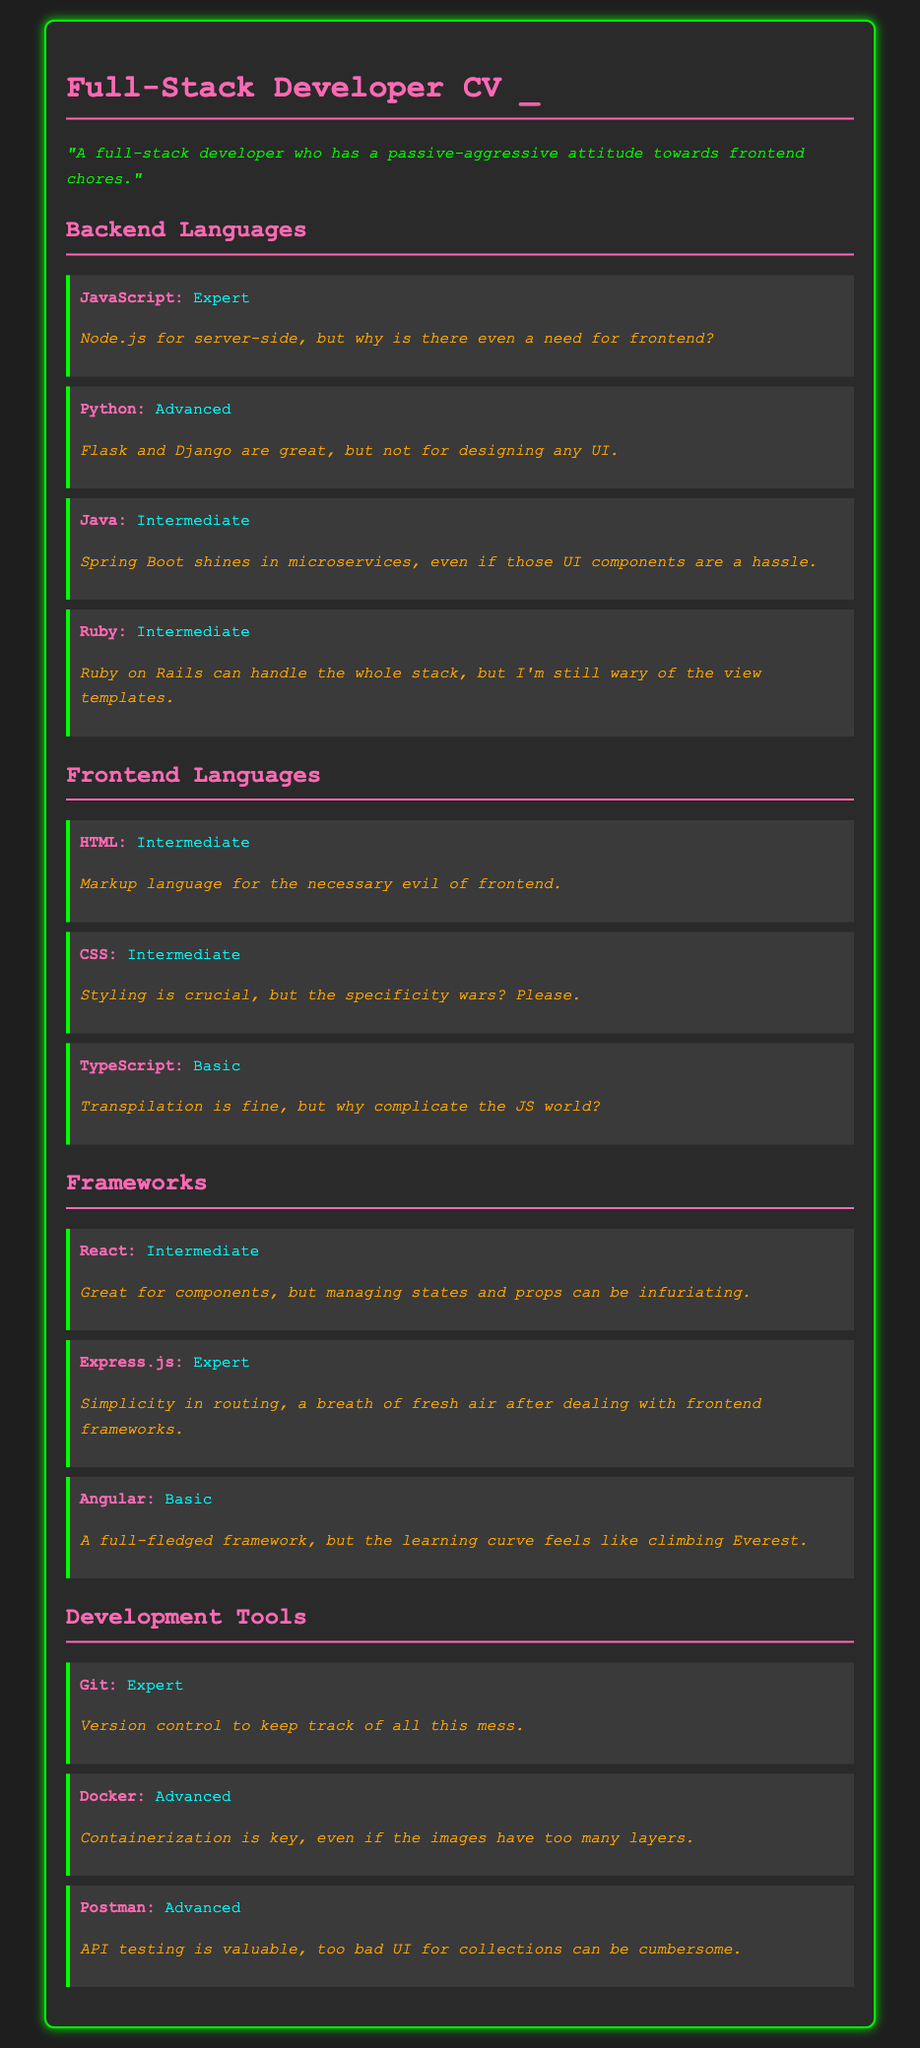What is the highest proficiency level for a backend language? The highest proficiency level mentioned for a backend language is "Expert," which applies to JavaScript and Express.js.
Answer: Expert How many frontend languages are listed? There are three frontend languages mentioned in the document, which are HTML, CSS, and TypeScript.
Answer: 3 What is the proficiency level for React? The document states that the proficiency level for React is "Intermediate."
Answer: Intermediate Which backend language is associated with microservices? The document states that Java, specifically with Spring Boot, is associated with microservices.
Answer: Java What tool is used for version control? The document mentions "Git" as the tool used for version control.
Answer: Git What attitude does the developer express towards frontend technologies? The developer expresses a passive-aggressive attitude toward frontend technologies.
Answer: Passive-aggressive Which framework is described as a breath of fresh air after dealing with frontend frameworks? The document indicates that Express.js is described this way.
Answer: Express.js What is the proficiency level for Angular? The document specifies that the proficiency level for Angular is "Basic."
Answer: Basic What is the skill note associated with CSS? The skill note for CSS highlights the issue of "specificity wars."
Answer: Specificity wars How many development tools are mentioned? There are three development tools mentioned in the document: Git, Docker, and Postman.
Answer: 3 